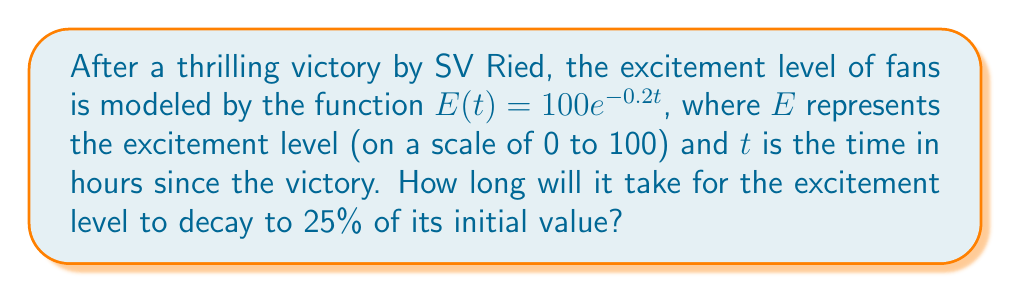Can you solve this math problem? To solve this problem, we need to follow these steps:

1) The initial excitement level is $E(0) = 100e^{-0.2(0)} = 100$.

2) We want to find when the excitement level is 25% of the initial value. This means:

   $E(t) = 0.25 \cdot 100 = 25$

3) We can set up the equation:

   $25 = 100e^{-0.2t}$

4) Divide both sides by 100:

   $0.25 = e^{-0.2t}$

5) Take the natural logarithm of both sides:

   $\ln(0.25) = \ln(e^{-0.2t})$

6) Simplify the right side using the properties of logarithms:

   $\ln(0.25) = -0.2t$

7) Solve for $t$:

   $t = -\frac{\ln(0.25)}{0.2}$

8) Calculate the result:

   $t = -\frac{\ln(0.25)}{0.2} \approx 6.93$ hours

Therefore, it will take approximately 6.93 hours for the excitement level to decay to 25% of its initial value after an SV Ried victory.
Answer: $t \approx 6.93$ hours 